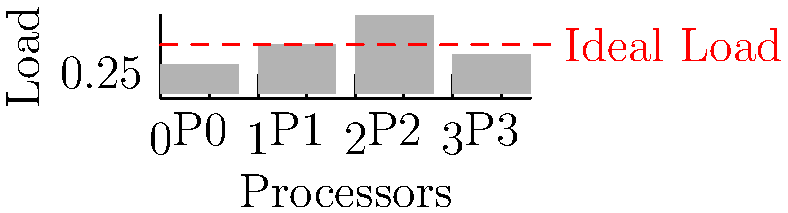Given the diagram showing the current load distribution across four processors (P0, P1, P2, P3) in a parallel computing system, which processor should data be redistributed from to achieve better load balancing, and to which processor should it be moved? To optimize data distribution and achieve better load balancing, we need to follow these steps:

1. Identify the current load distribution:
   P0: 0.3
   P1: 0.5
   P2: 0.8
   P3: 0.4

2. Calculate the ideal balanced load:
   Total load = 0.3 + 0.5 + 0.8 + 0.4 = 2.0
   Ideal load per processor = 2.0 / 4 = 0.5

3. Identify overloaded and underloaded processors:
   Overloaded: P2 (0.8 > 0.5)
   Underloaded: P0 (0.3 < 0.5) and P3 (0.4 < 0.5)

4. Determine the amount of load to redistribute:
   Excess load on P2 = 0.8 - 0.5 = 0.3

5. Choose the processor to receive the redistributed load:
   P0 can receive up to 0.2 more (0.5 - 0.3)
   P3 can receive up to 0.1 more (0.5 - 0.4)

6. Redistribute the load:
   Move 0.2 from P2 to P0
   Move 0.1 from P2 to P3

This redistribution will result in a more balanced load:
P0: 0.5, P1: 0.5, P2: 0.5, P3: 0.5
Answer: Redistribute 0.2 from P2 to P0 and 0.1 from P2 to P3 